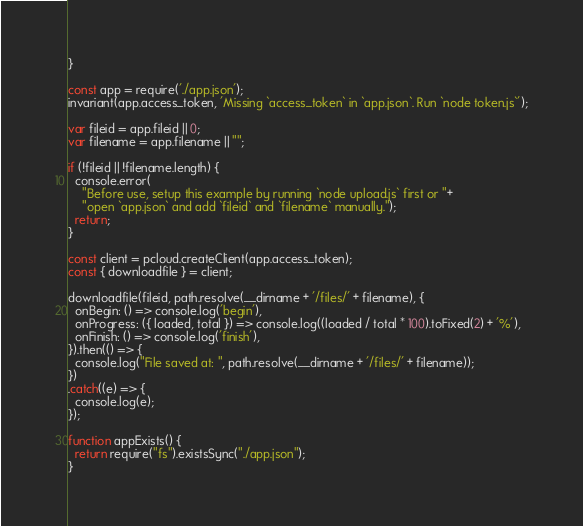Convert code to text. <code><loc_0><loc_0><loc_500><loc_500><_JavaScript_>}

const app = require('./app.json');
invariant(app.access_token, 'Missing `access_token` in `app.json`. Run `node token.js`');

var fileid = app.fileid || 0;
var filename = app.filename || "";

if (!fileid || !filename.length) {
  console.error(
    "Before use, setup this example by running `node upload.js` first or "+
    "open `app.json` and add `fileid` and `filename` manually.");
  return;
}

const client = pcloud.createClient(app.access_token);
const { downloadfile } = client;

downloadfile(fileid, path.resolve(__dirname + '/files/' + filename), {
  onBegin: () => console.log('begin'),
  onProgress: ({ loaded, total }) => console.log((loaded / total * 100).toFixed(2) + '%'),
  onFinish: () => console.log('finish'),
}).then(() => {
  console.log("File saved at: ", path.resolve(__dirname + '/files/' + filename));
})
.catch((e) => {
  console.log(e);
});

function appExists() {
  return require("fs").existsSync("./app.json");
}
</code> 